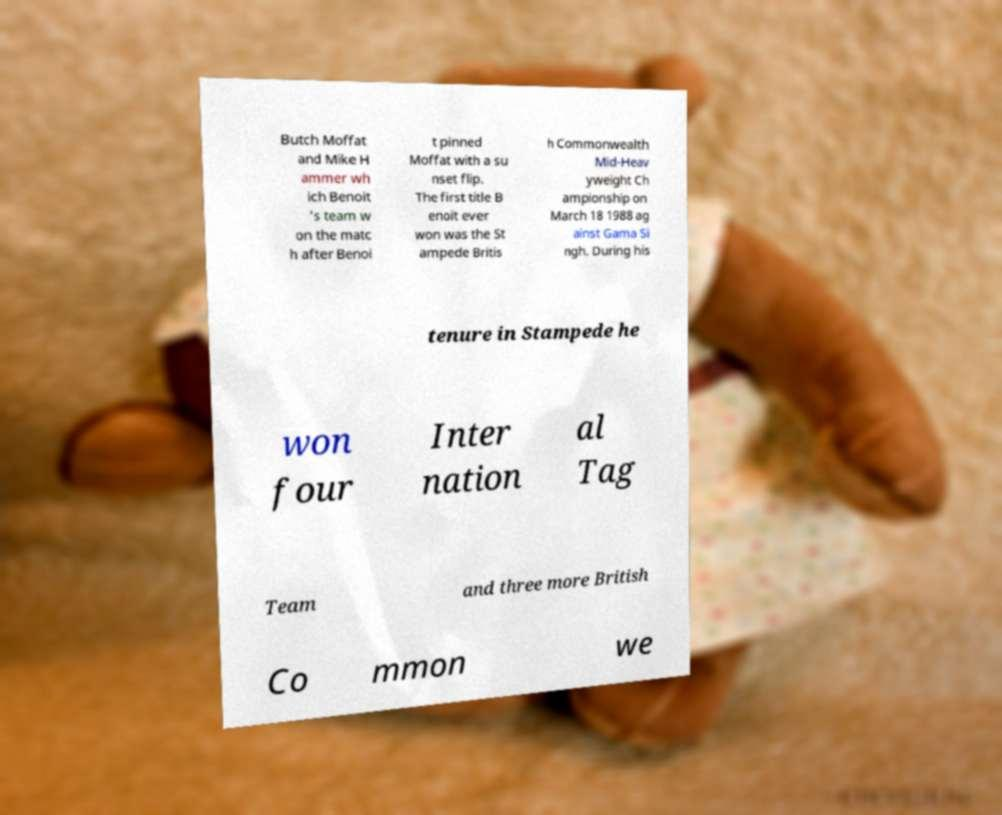Please read and relay the text visible in this image. What does it say? Butch Moffat and Mike H ammer wh ich Benoit 's team w on the matc h after Benoi t pinned Moffat with a su nset flip. The first title B enoit ever won was the St ampede Britis h Commonwealth Mid-Heav yweight Ch ampionship on March 18 1988 ag ainst Gama Si ngh. During his tenure in Stampede he won four Inter nation al Tag Team and three more British Co mmon we 